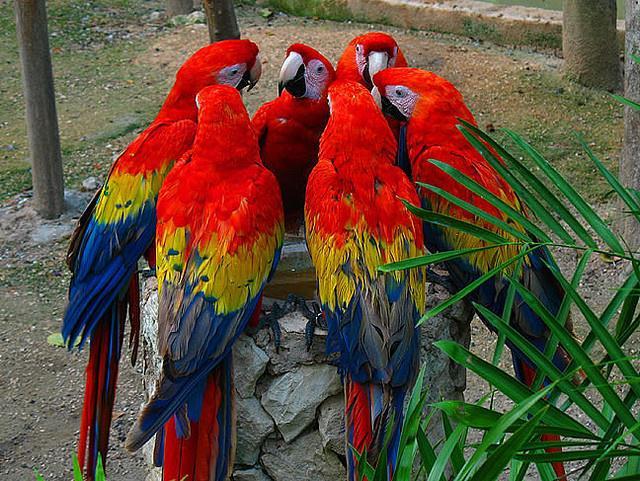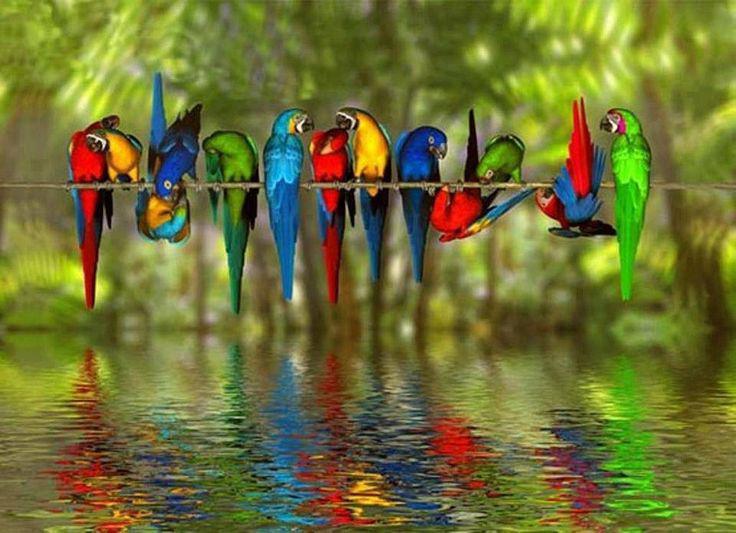The first image is the image on the left, the second image is the image on the right. Assess this claim about the two images: "There are six colorful birds perched on a piece of wood in the image on the left.". Correct or not? Answer yes or no. No. The first image is the image on the left, the second image is the image on the right. For the images shown, is this caption "The parrot in the right image closest to the right side is blue and yellow." true? Answer yes or no. No. 